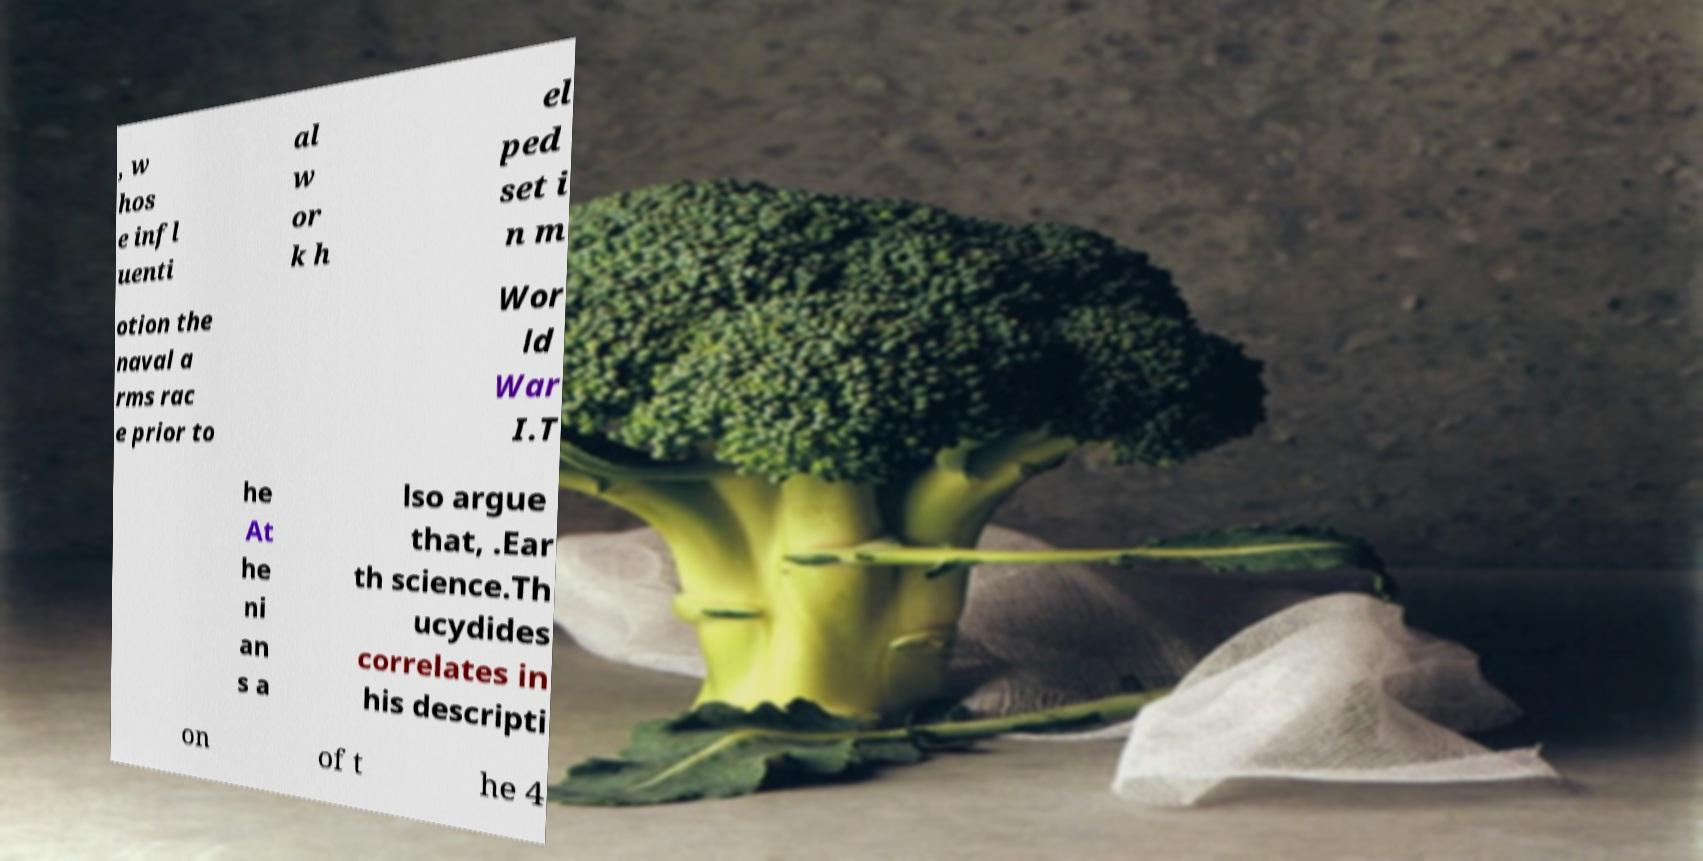I need the written content from this picture converted into text. Can you do that? , w hos e infl uenti al w or k h el ped set i n m otion the naval a rms rac e prior to Wor ld War I.T he At he ni an s a lso argue that, .Ear th science.Th ucydides correlates in his descripti on of t he 4 